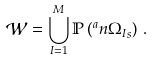Convert formula to latex. <formula><loc_0><loc_0><loc_500><loc_500>\mathcal { W } = \bigcup _ { I = 1 } ^ { M } \mathbb { P } \left ( ^ { a } n { \Omega _ { I } } _ { \real s } \right ) \, .</formula> 